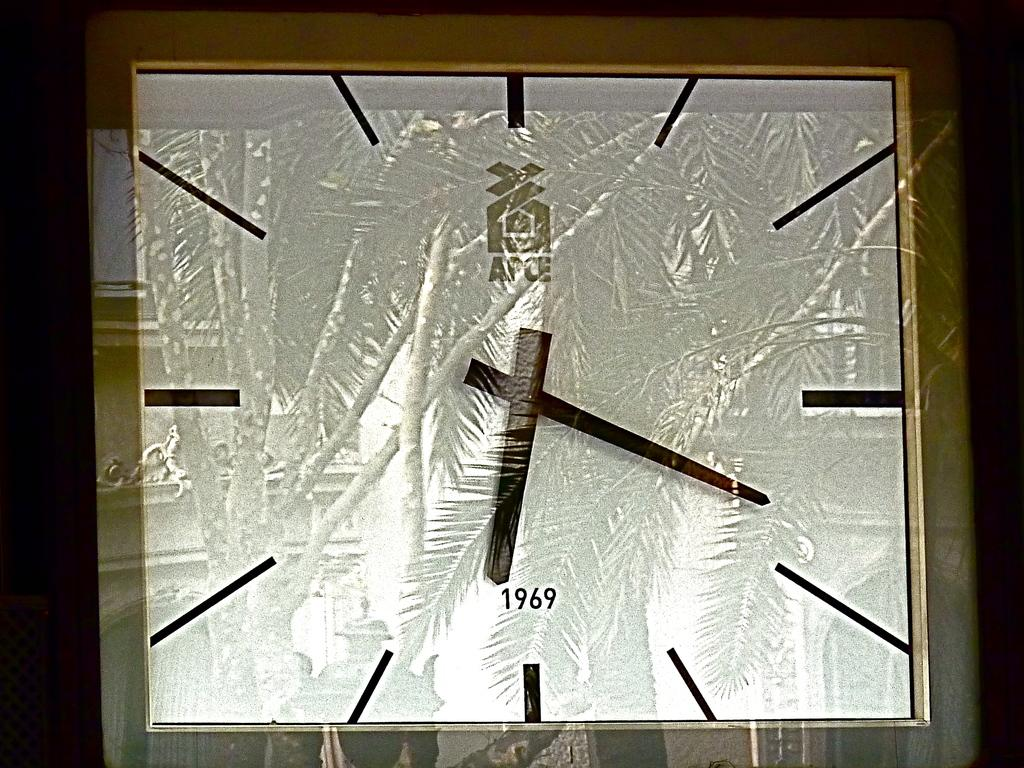<image>
Render a clear and concise summary of the photo. A silver square clock says 1969 on the face. 